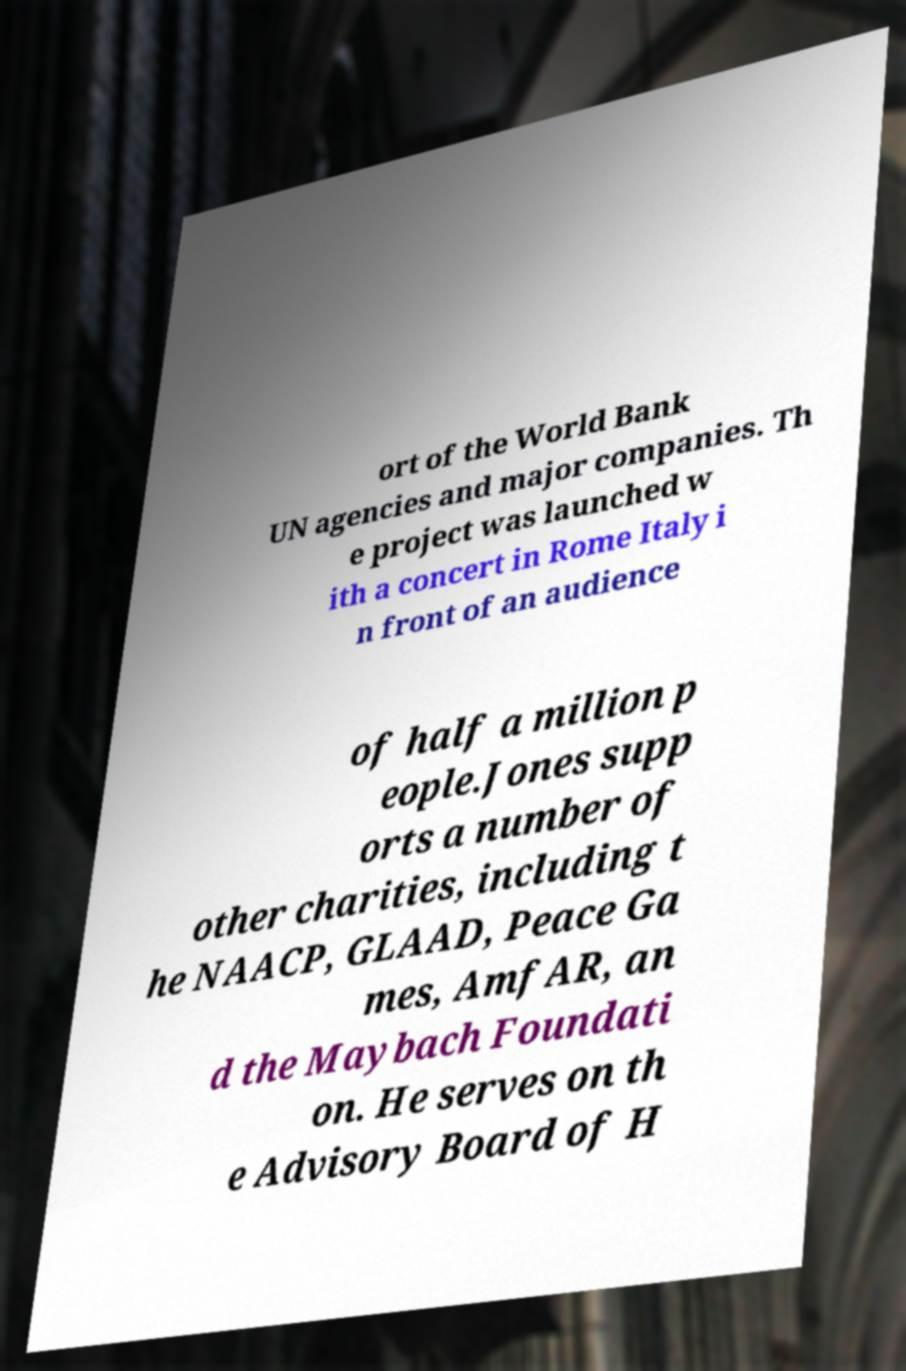For documentation purposes, I need the text within this image transcribed. Could you provide that? ort of the World Bank UN agencies and major companies. Th e project was launched w ith a concert in Rome Italy i n front of an audience of half a million p eople.Jones supp orts a number of other charities, including t he NAACP, GLAAD, Peace Ga mes, AmfAR, an d the Maybach Foundati on. He serves on th e Advisory Board of H 